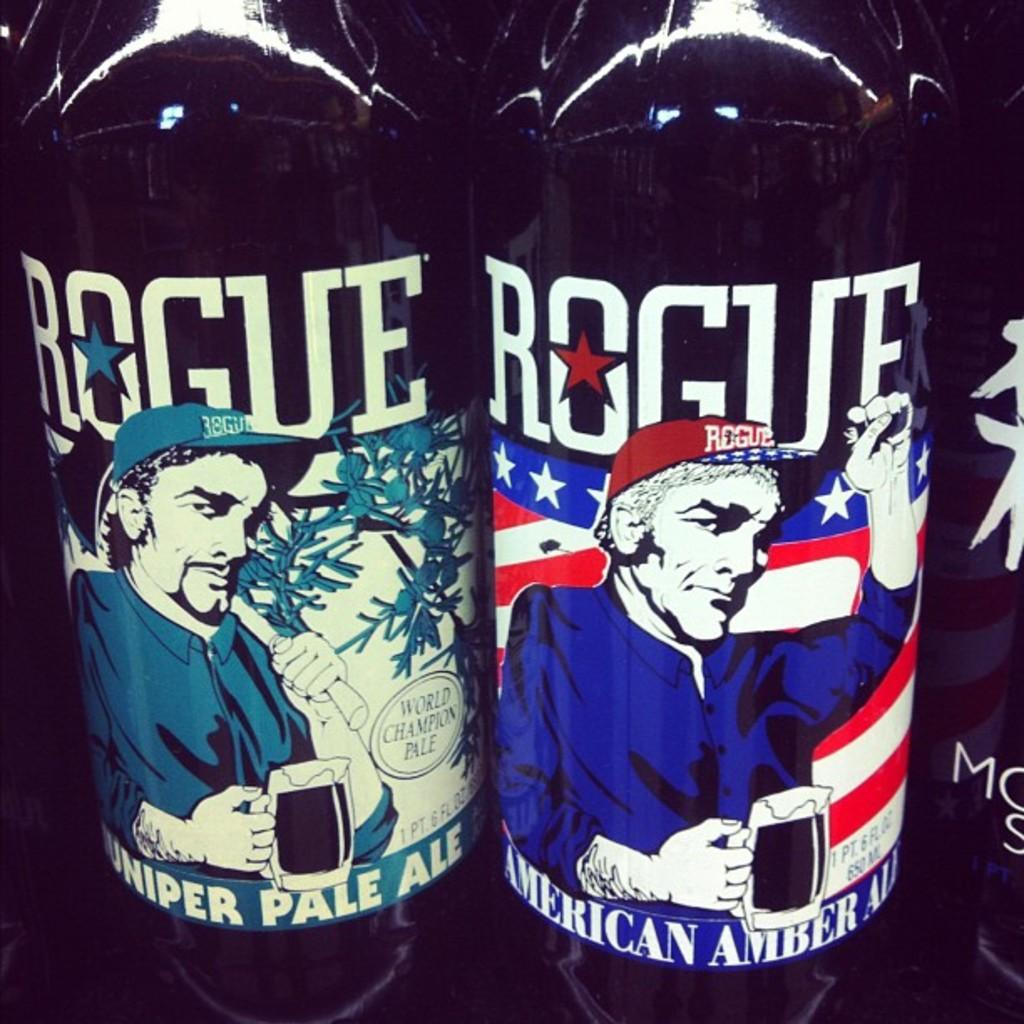<image>
Share a concise interpretation of the image provided. Two bottles of Rogue American Ale are standing besides each other. 